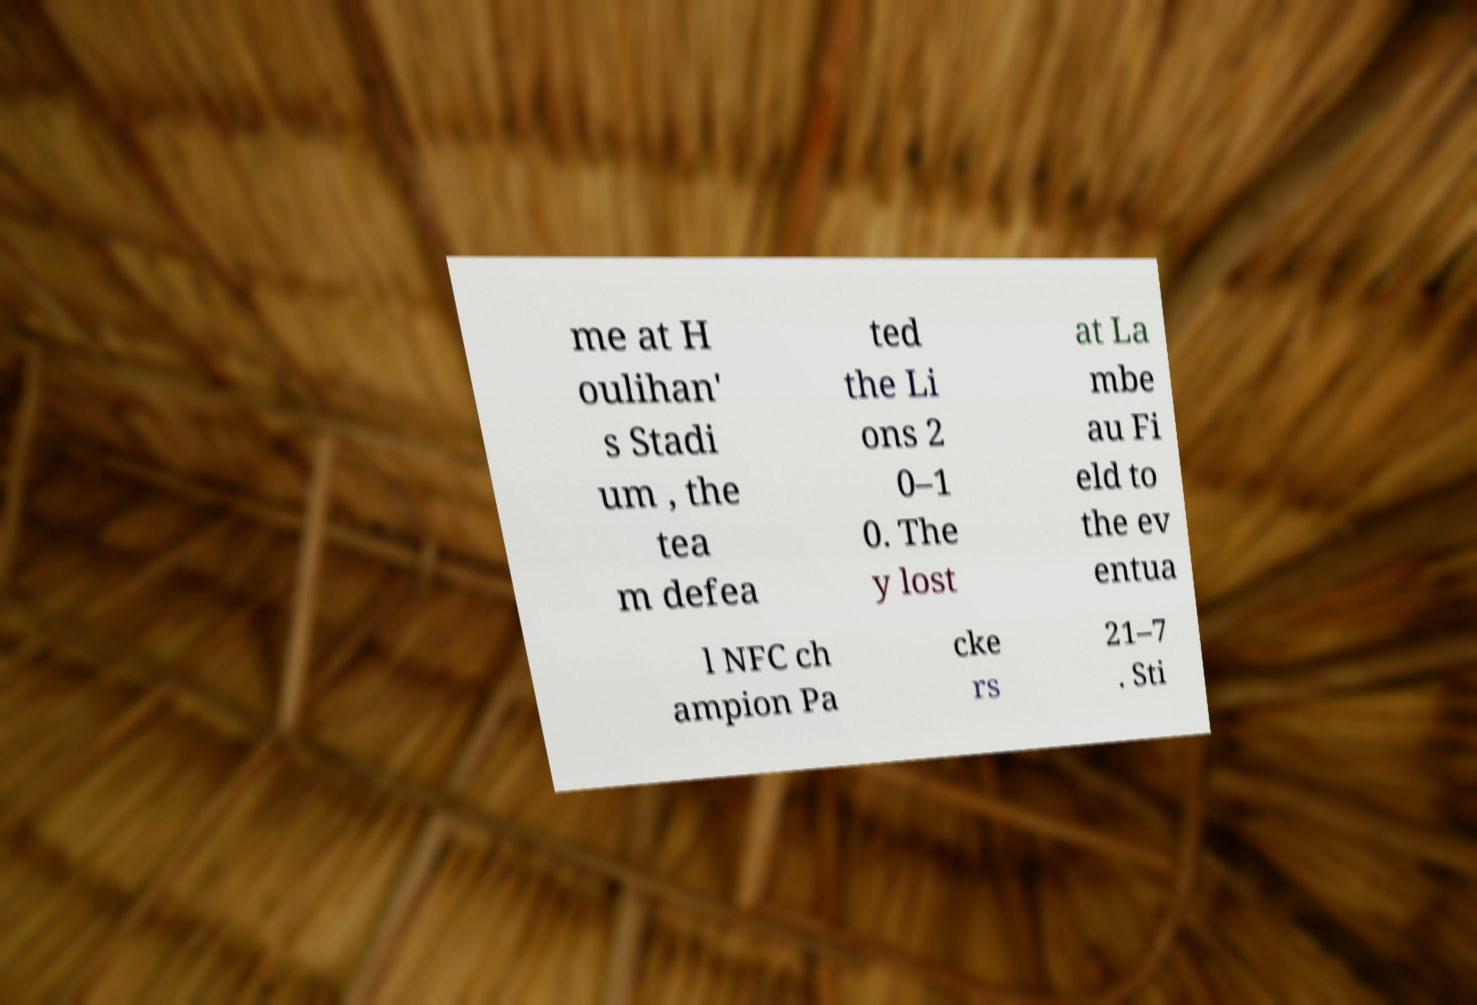There's text embedded in this image that I need extracted. Can you transcribe it verbatim? me at H oulihan' s Stadi um , the tea m defea ted the Li ons 2 0–1 0. The y lost at La mbe au Fi eld to the ev entua l NFC ch ampion Pa cke rs 21–7 . Sti 